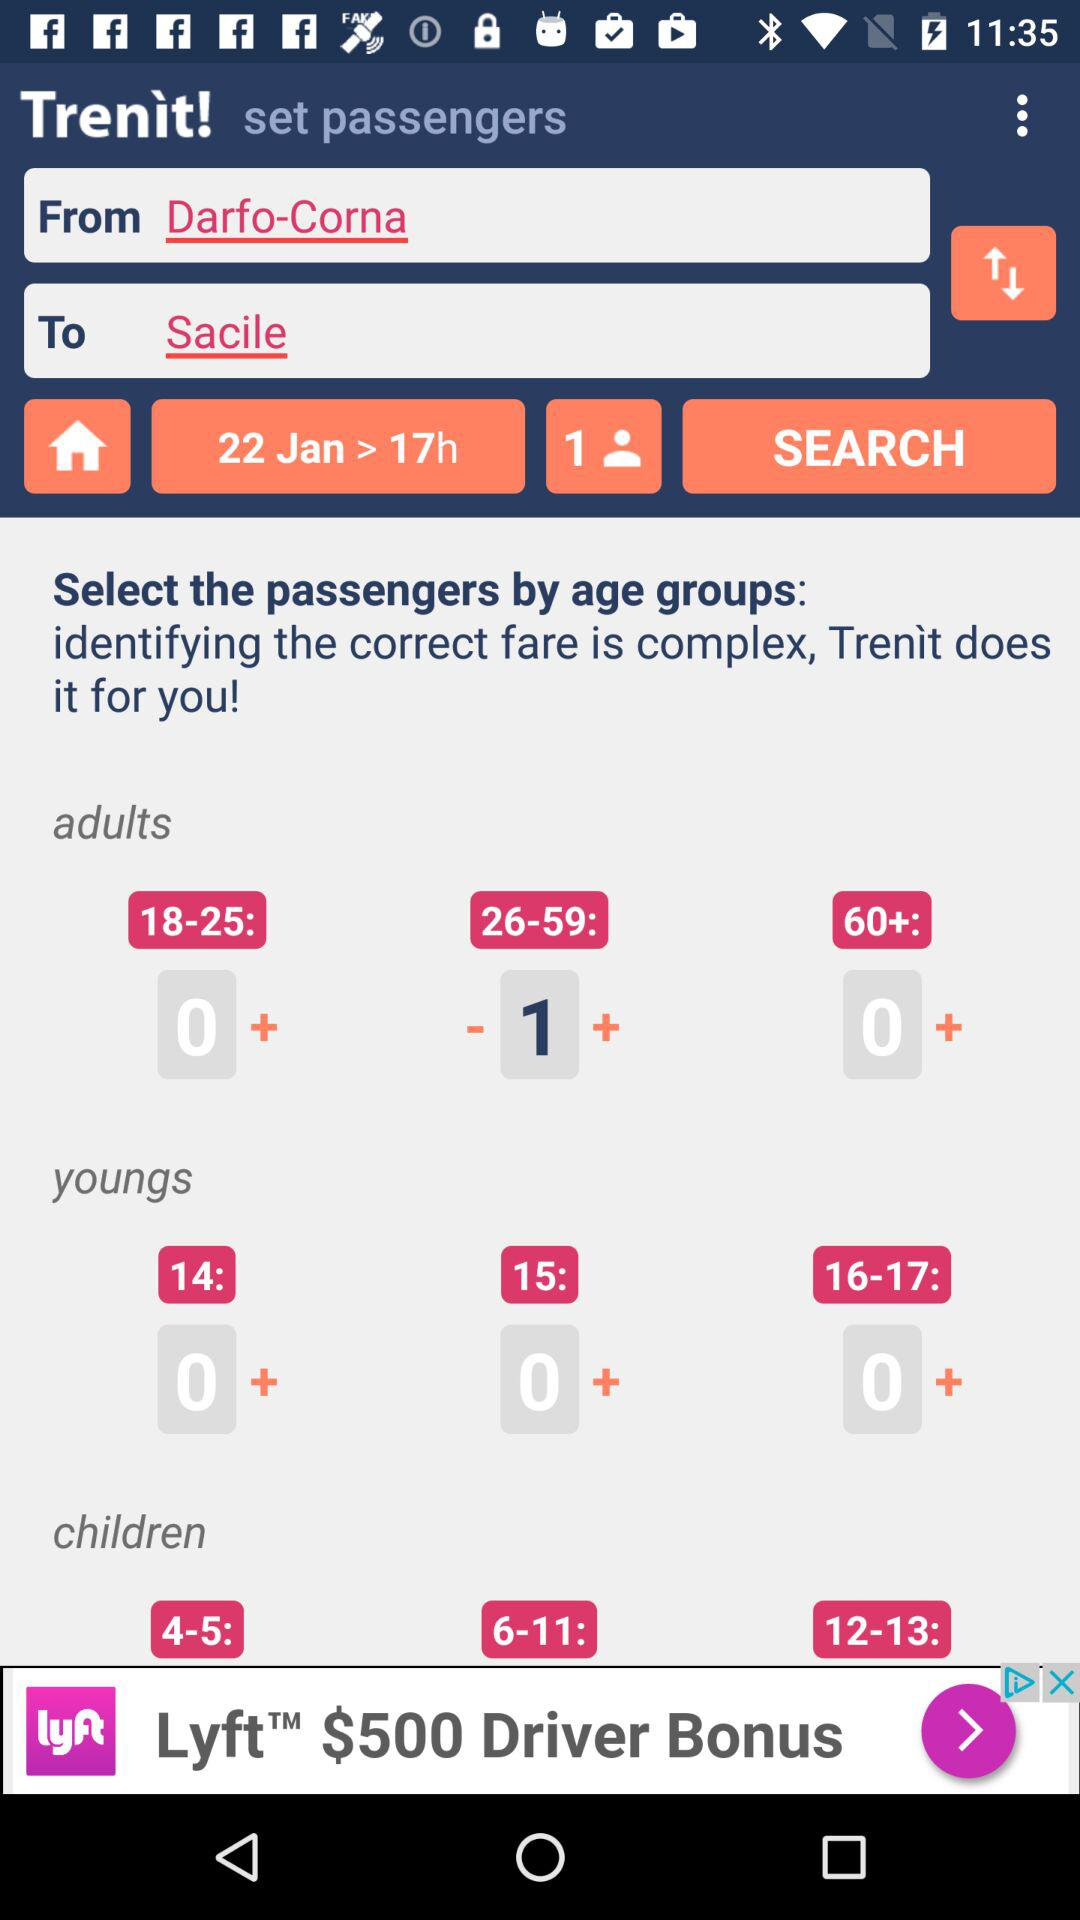How many age groups are there for children?
Answer the question using a single word or phrase. 3 